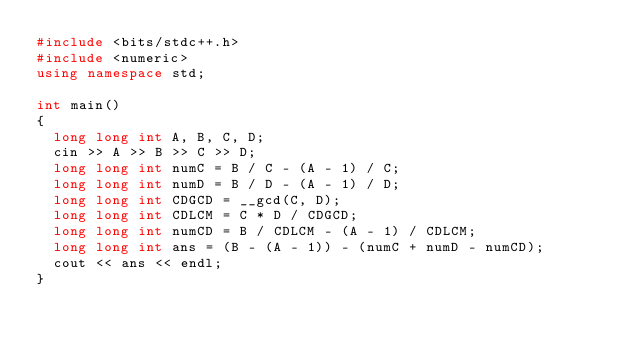<code> <loc_0><loc_0><loc_500><loc_500><_C++_>#include <bits/stdc++.h>
#include <numeric>
using namespace std;

int main()
{
  long long int A, B, C, D;
  cin >> A >> B >> C >> D;
  long long int numC = B / C - (A - 1) / C;
  long long int numD = B / D - (A - 1) / D;
  long long int CDGCD = __gcd(C, D);
  long long int CDLCM = C * D / CDGCD;
  long long int numCD = B / CDLCM - (A - 1) / CDLCM;
  long long int ans = (B - (A - 1)) - (numC + numD - numCD);
  cout << ans << endl;
}
</code> 